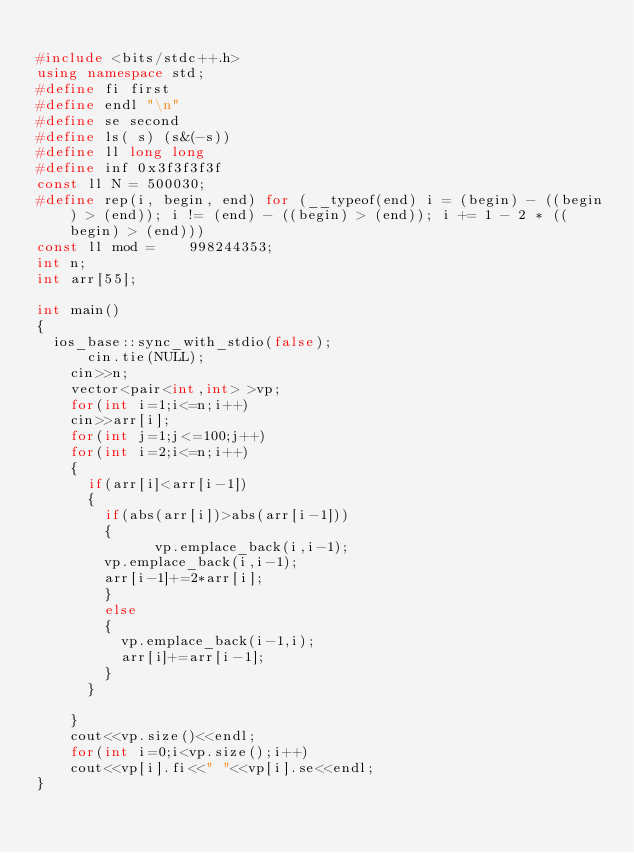Convert code to text. <code><loc_0><loc_0><loc_500><loc_500><_C++_>
#include <bits/stdc++.h>
using namespace std;
#define fi first
#define endl "\n"
#define se second
#define ls( s) (s&(-s))
#define ll long long
#define inf 0x3f3f3f3f
const ll N = 500030;
#define rep(i, begin, end) for (__typeof(end) i = (begin) - ((begin) > (end)); i != (end) - ((begin) > (end)); i += 1 - 2 * ((begin) > (end)))
const ll mod =    998244353;
int n;
int arr[55];

int main()
{
	ios_base::sync_with_stdio(false);
	    cin.tie(NULL);
	  cin>>n;
	  vector<pair<int,int> >vp;
	  for(int i=1;i<=n;i++)
	  cin>>arr[i];
	  for(int j=1;j<=100;j++)
	  for(int i=2;i<=n;i++)
	  {
	  	if(arr[i]<arr[i-1])
	  	{
	  		if(abs(arr[i])>abs(arr[i-1]))
	  		{
	            vp.emplace_back(i,i-1);
				vp.emplace_back(i,i-1);
				arr[i-1]+=2*arr[i];
			  }
			  else
			  {
			  	vp.emplace_back(i-1,i);
			  	arr[i]+=arr[i-1];
			  }
		  }
		  
	  }
	  cout<<vp.size()<<endl;
	  for(int i=0;i<vp.size();i++)
	  cout<<vp[i].fi<<" "<<vp[i].se<<endl;
}
</code> 